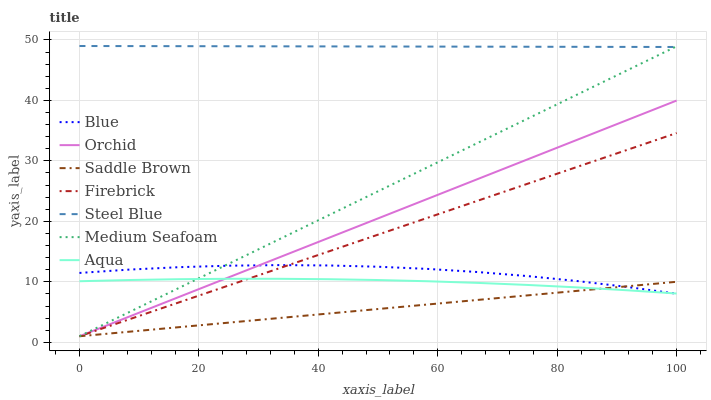Does Saddle Brown have the minimum area under the curve?
Answer yes or no. Yes. Does Steel Blue have the maximum area under the curve?
Answer yes or no. Yes. Does Firebrick have the minimum area under the curve?
Answer yes or no. No. Does Firebrick have the maximum area under the curve?
Answer yes or no. No. Is Saddle Brown the smoothest?
Answer yes or no. Yes. Is Blue the roughest?
Answer yes or no. Yes. Is Firebrick the smoothest?
Answer yes or no. No. Is Firebrick the roughest?
Answer yes or no. No. Does Firebrick have the lowest value?
Answer yes or no. Yes. Does Aqua have the lowest value?
Answer yes or no. No. Does Steel Blue have the highest value?
Answer yes or no. Yes. Does Firebrick have the highest value?
Answer yes or no. No. Is Aqua less than Steel Blue?
Answer yes or no. Yes. Is Steel Blue greater than Blue?
Answer yes or no. Yes. Does Aqua intersect Blue?
Answer yes or no. Yes. Is Aqua less than Blue?
Answer yes or no. No. Is Aqua greater than Blue?
Answer yes or no. No. Does Aqua intersect Steel Blue?
Answer yes or no. No. 